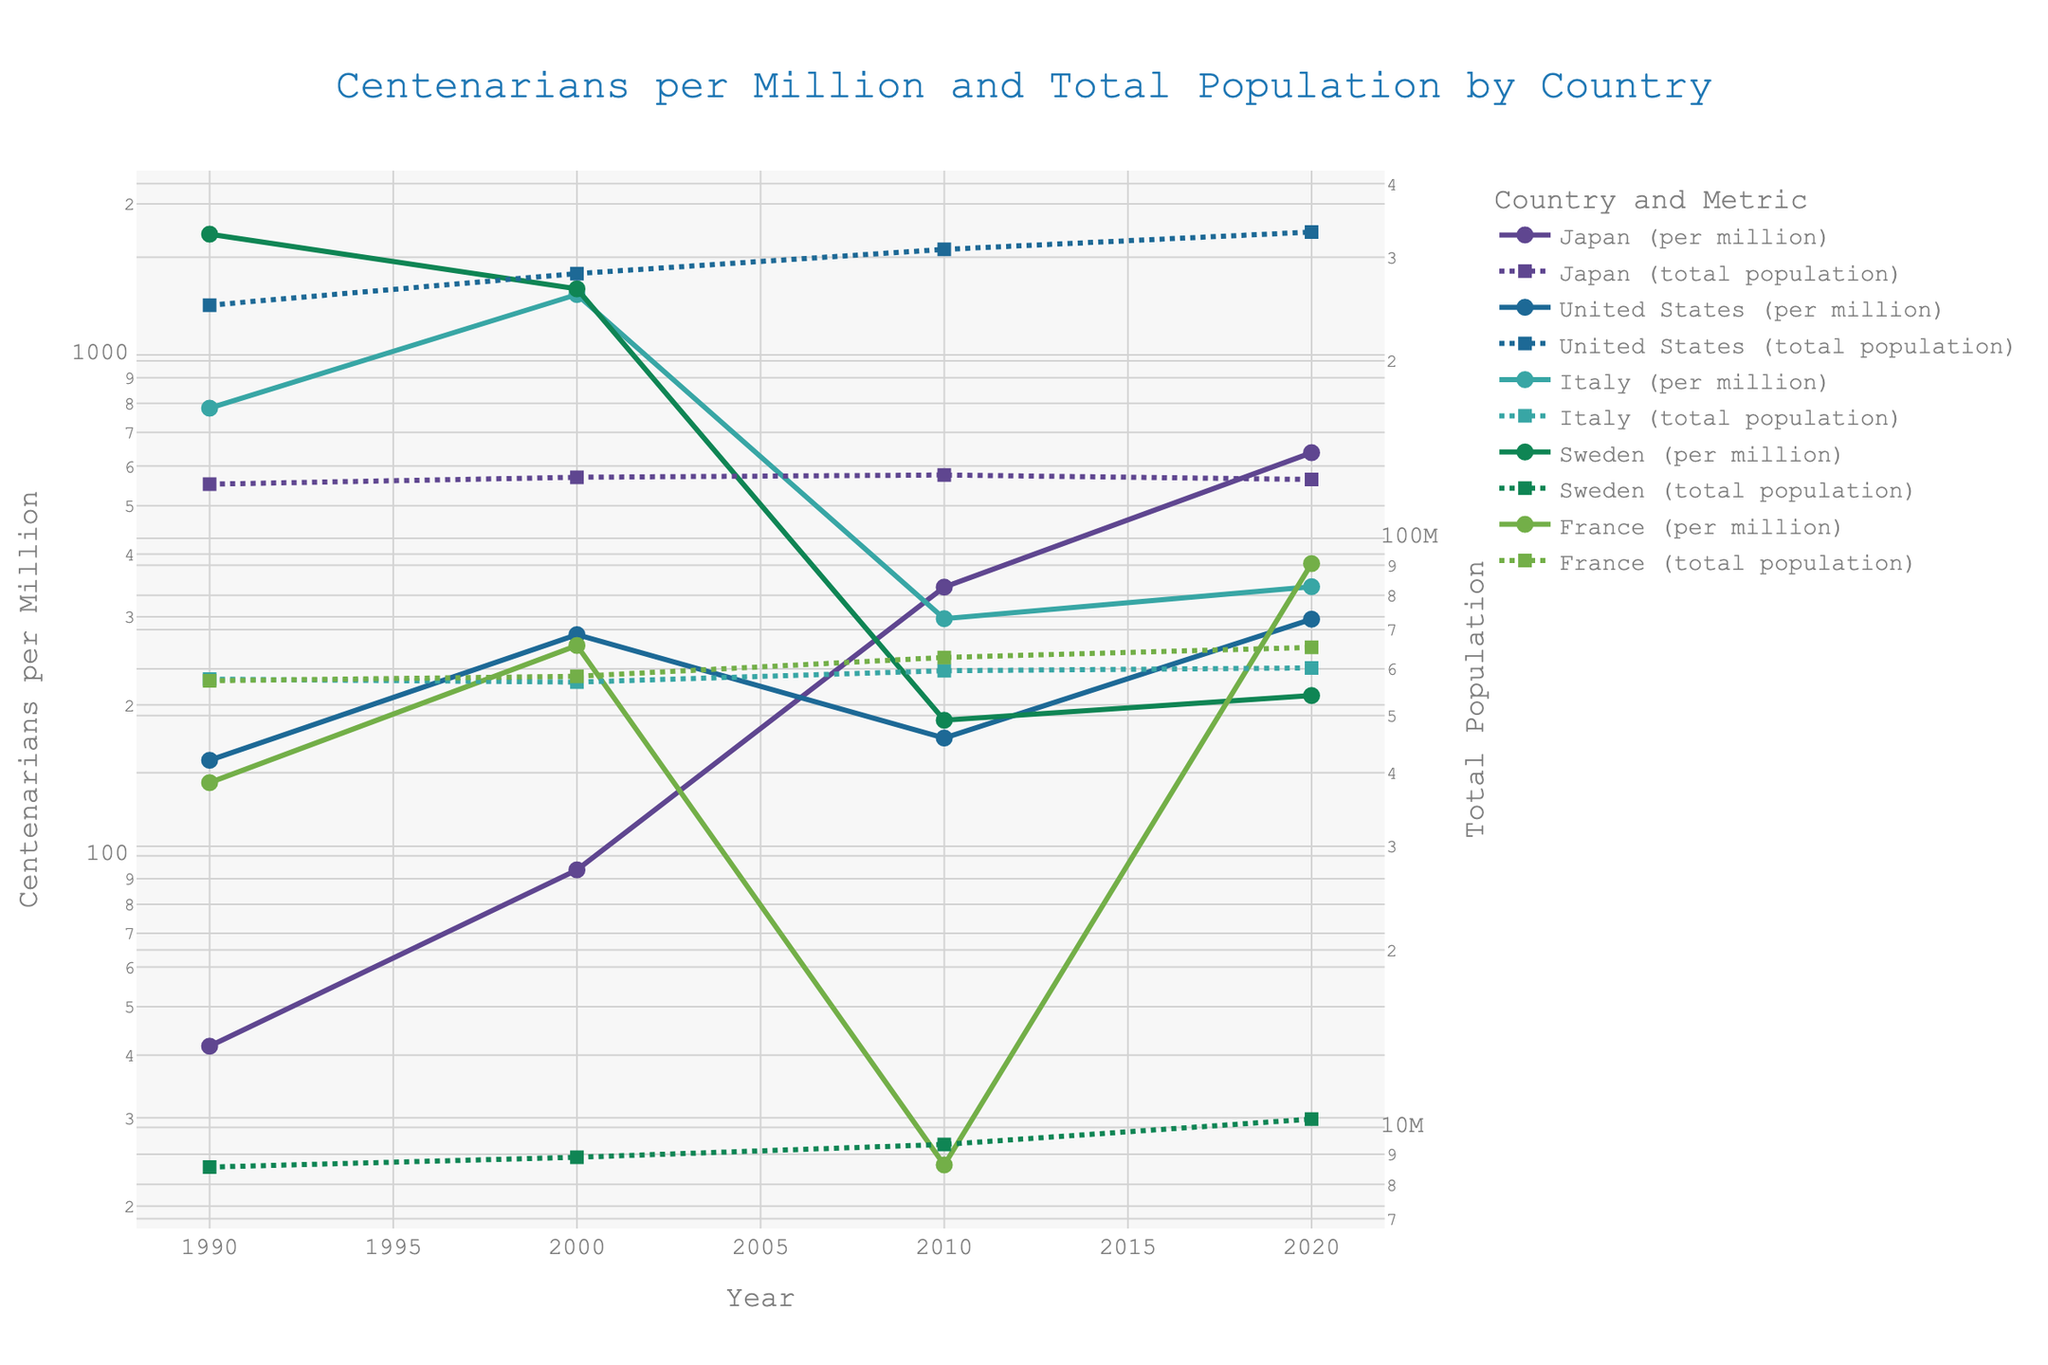What is the title of the figure? The title is usually placed at the top center of the plot. It provides an overall description of what the figure represents.
Answer: Centenarians per Million and Total Population by Country Which country had the highest number of centenarians per million in 2020? Look across the '2020' data points on the primary y-axis (centenarians per million) and identify the highest one.
Answer: Japan What is the trend in the total population of Japan from 1990 to 2020? Follow the dashed line for Japan from 1990 to 2020 on the secondary y-axis that displays total population. The line represents the population size variations over the years.
Answer: Generally decreasing with slight fluctuations Between 2000 and 2010, which country saw a decrease in centenarians per million? Examine the centenarians per million line (solid lines) for each country between 2000 and 2010. Identify if any line shows a downward trend.
Answer: Sweden and Italy In 2010, how does the number of centenarians per million in the United States compare to that in Japan? Locate the 2010 data points for the centenarians per million for both countries and compare their values.
Answer: Higher in Japan than the United States Which country has shown the most significant increase in centenarians per million from 1990 to 2020? Calculate the increase by subtracting the 1990 values from the 2020 values for each country and identify the largest difference.
Answer: Japan Around which year did Italy's total population start showing a declining trend? Look at the secondary y-axis lines representing Italy's total population and identify the year when it starts to decline.
Answer: Around 2000 By comparing all countries, which one has the smallest total population in 2020? Check the values at the end of the dashed lines representing the total population for all countries and find the smallest one.
Answer: Sweden What kind of scale is used on the y-axes of the figure? Analyze the y-axis to determine if they follow any specific scaling method like linear, logarithmic, etc. Look for visual cues such as grid lines and scale intervals.
Answer: Logarithmic scale In the year 2000, which had a higher centenarians per million, Italy or France? Compare the centenarians per million values of Italy and France for the year 2000.
Answer: Italy What can you infer about the trend of centenarians per million in France from 1990 to 2020? Observe the changes in the centenarians per million line for France across these years to identify any increasing, decreasing or stable trends.
Answer: Increasing trend with fluctuations 